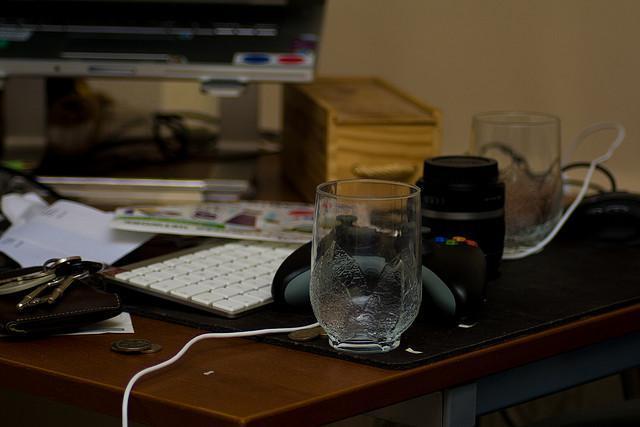How many glasses are there?
Give a very brief answer. 2. How many glasses is seen?
Give a very brief answer. 2. How many cups can you see?
Give a very brief answer. 2. How many mice are in the photo?
Give a very brief answer. 2. 